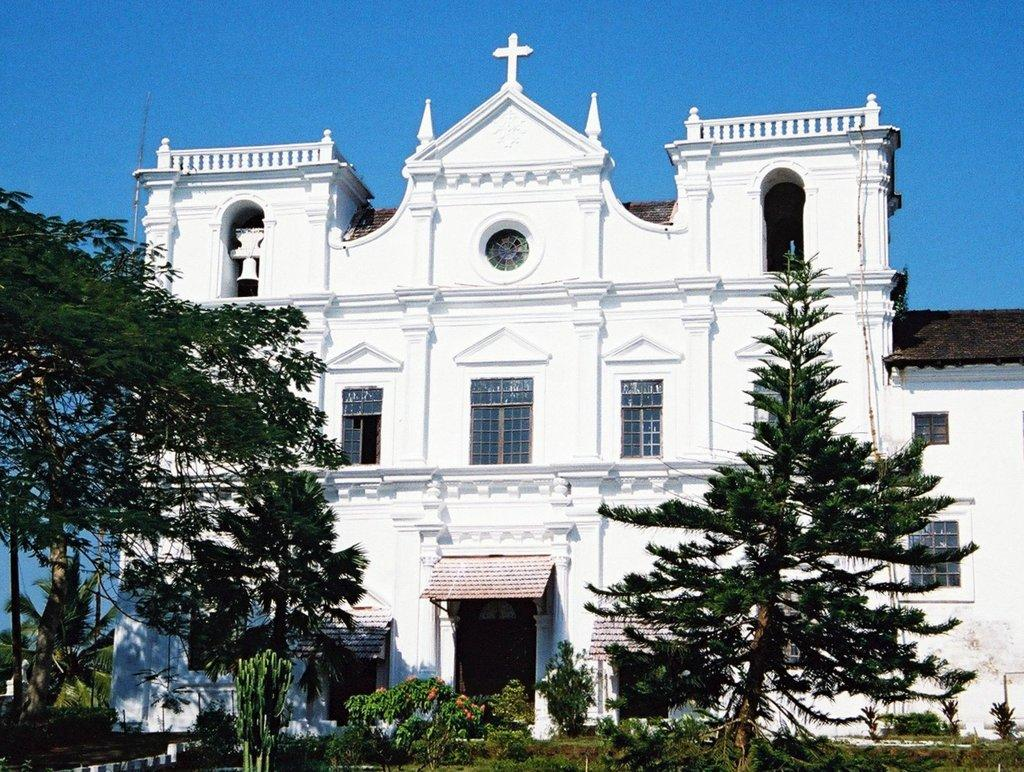What is the main structure in the middle of the image? There is a church in the middle of the image. What type of vegetation can be seen in the image? There are plants, trees, and flowers in the image. What is visible at the top of the image? The sky is visible at the top of the image. How many moms are sitting on the chairs in the image? There are no chairs or moms present in the image. What type of spiders can be seen crawling on the flowers in the image? There are no spiders visible in the image; it only features plants, trees, and flowers. 